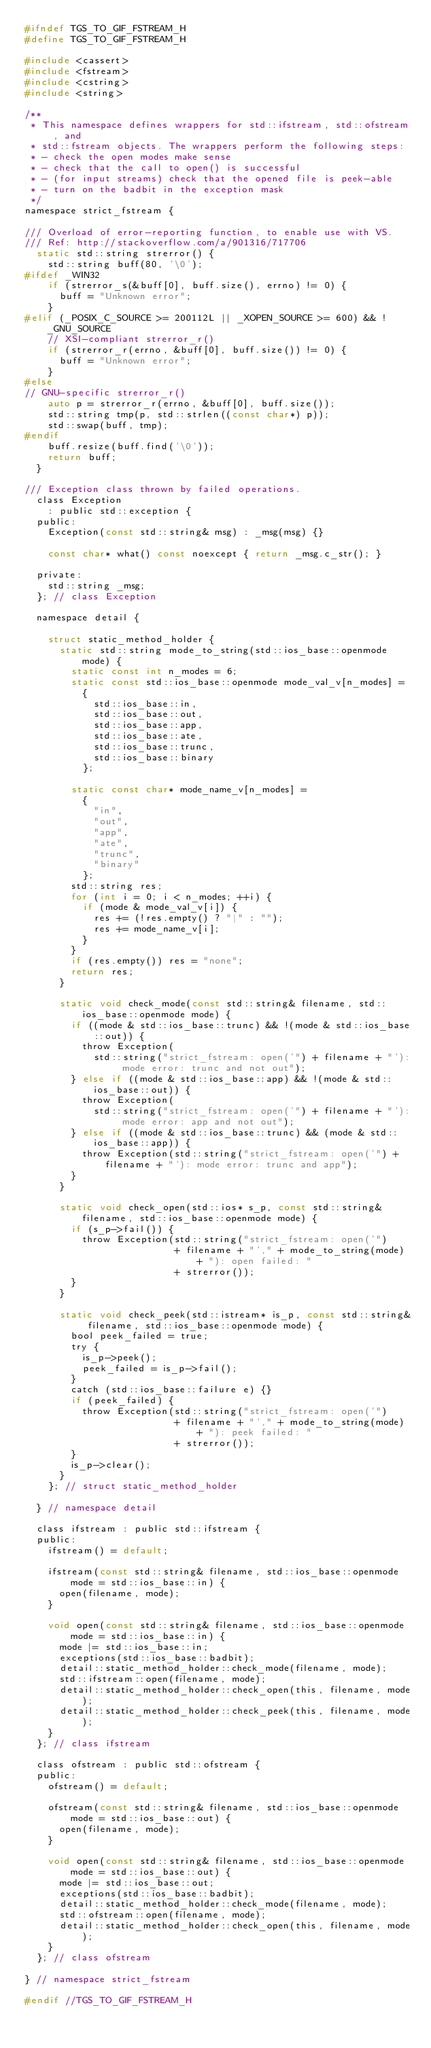Convert code to text. <code><loc_0><loc_0><loc_500><loc_500><_C_>#ifndef TGS_TO_GIF_FSTREAM_H
#define TGS_TO_GIF_FSTREAM_H

#include <cassert>
#include <fstream>
#include <cstring>
#include <string>

/**
 * This namespace defines wrappers for std::ifstream, std::ofstream, and
 * std::fstream objects. The wrappers perform the following steps:
 * - check the open modes make sense
 * - check that the call to open() is successful
 * - (for input streams) check that the opened file is peek-able
 * - turn on the badbit in the exception mask
 */
namespace strict_fstream {

/// Overload of error-reporting function, to enable use with VS.
/// Ref: http://stackoverflow.com/a/901316/717706
	static std::string strerror() {
		std::string buff(80, '\0');
#ifdef _WIN32
		if (strerror_s(&buff[0], buff.size(), errno) != 0) {
			buff = "Unknown error";
		}
#elif (_POSIX_C_SOURCE >= 200112L || _XOPEN_SOURCE >= 600) && !_GNU_SOURCE
		// XSI-compliant strerror_r()
		if (strerror_r(errno, &buff[0], buff.size()) != 0) {
			buff = "Unknown error";
		}
#else
// GNU-specific strerror_r()
		auto p = strerror_r(errno, &buff[0], buff.size());
		std::string tmp(p, std::strlen((const char*) p));
		std::swap(buff, tmp);
#endif
		buff.resize(buff.find('\0'));
		return buff;
	}

/// Exception class thrown by failed operations.
	class Exception
		: public std::exception {
	public:
		Exception(const std::string& msg) : _msg(msg) {}

		const char* what() const noexcept { return _msg.c_str(); }

	private:
		std::string _msg;
	}; // class Exception

	namespace detail {

		struct static_method_holder {
			static std::string mode_to_string(std::ios_base::openmode mode) {
				static const int n_modes = 6;
				static const std::ios_base::openmode mode_val_v[n_modes] =
					{
						std::ios_base::in,
						std::ios_base::out,
						std::ios_base::app,
						std::ios_base::ate,
						std::ios_base::trunc,
						std::ios_base::binary
					};

				static const char* mode_name_v[n_modes] =
					{
						"in",
						"out",
						"app",
						"ate",
						"trunc",
						"binary"
					};
				std::string res;
				for (int i = 0; i < n_modes; ++i) {
					if (mode & mode_val_v[i]) {
						res += (!res.empty() ? "|" : "");
						res += mode_name_v[i];
					}
				}
				if (res.empty()) res = "none";
				return res;
			}

			static void check_mode(const std::string& filename, std::ios_base::openmode mode) {
				if ((mode & std::ios_base::trunc) && !(mode & std::ios_base::out)) {
					throw Exception(
						std::string("strict_fstream: open('") + filename + "'): mode error: trunc and not out");
				} else if ((mode & std::ios_base::app) && !(mode & std::ios_base::out)) {
					throw Exception(
						std::string("strict_fstream: open('") + filename + "'): mode error: app and not out");
				} else if ((mode & std::ios_base::trunc) && (mode & std::ios_base::app)) {
					throw Exception(std::string("strict_fstream: open('") + filename + "'): mode error: trunc and app");
				}
			}

			static void check_open(std::ios* s_p, const std::string& filename, std::ios_base::openmode mode) {
				if (s_p->fail()) {
					throw Exception(std::string("strict_fstream: open('")
					                + filename + "'," + mode_to_string(mode) + "): open failed: "
					                + strerror());
				}
			}

			static void check_peek(std::istream* is_p, const std::string& filename, std::ios_base::openmode mode) {
				bool peek_failed = true;
				try {
					is_p->peek();
					peek_failed = is_p->fail();
				}
				catch (std::ios_base::failure e) {}
				if (peek_failed) {
					throw Exception(std::string("strict_fstream: open('")
					                + filename + "'," + mode_to_string(mode) + "): peek failed: "
					                + strerror());
				}
				is_p->clear();
			}
		}; // struct static_method_holder

	} // namespace detail

	class ifstream : public std::ifstream {
	public:
		ifstream() = default;

		ifstream(const std::string& filename, std::ios_base::openmode mode = std::ios_base::in) {
			open(filename, mode);
		}

		void open(const std::string& filename, std::ios_base::openmode mode = std::ios_base::in) {
			mode |= std::ios_base::in;
			exceptions(std::ios_base::badbit);
			detail::static_method_holder::check_mode(filename, mode);
			std::ifstream::open(filename, mode);
			detail::static_method_holder::check_open(this, filename, mode);
			detail::static_method_holder::check_peek(this, filename, mode);
		}
	}; // class ifstream

	class ofstream : public std::ofstream {
	public:
		ofstream() = default;

		ofstream(const std::string& filename, std::ios_base::openmode mode = std::ios_base::out) {
			open(filename, mode);
		}

		void open(const std::string& filename, std::ios_base::openmode mode = std::ios_base::out) {
			mode |= std::ios_base::out;
			exceptions(std::ios_base::badbit);
			detail::static_method_holder::check_mode(filename, mode);
			std::ofstream::open(filename, mode);
			detail::static_method_holder::check_open(this, filename, mode);
		}
	}; // class ofstream

} // namespace strict_fstream

#endif //TGS_TO_GIF_FSTREAM_H
</code> 